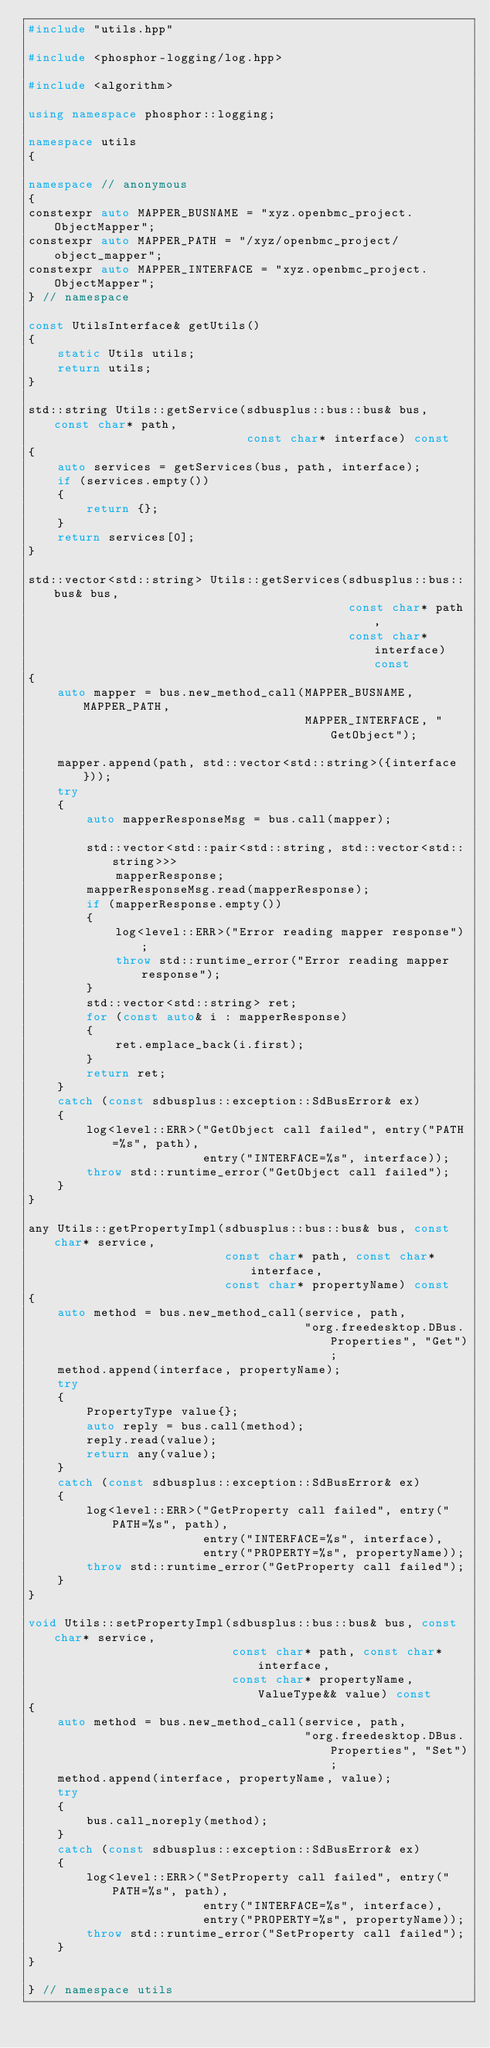Convert code to text. <code><loc_0><loc_0><loc_500><loc_500><_C++_>#include "utils.hpp"

#include <phosphor-logging/log.hpp>

#include <algorithm>

using namespace phosphor::logging;

namespace utils
{

namespace // anonymous
{
constexpr auto MAPPER_BUSNAME = "xyz.openbmc_project.ObjectMapper";
constexpr auto MAPPER_PATH = "/xyz/openbmc_project/object_mapper";
constexpr auto MAPPER_INTERFACE = "xyz.openbmc_project.ObjectMapper";
} // namespace

const UtilsInterface& getUtils()
{
    static Utils utils;
    return utils;
}

std::string Utils::getService(sdbusplus::bus::bus& bus, const char* path,
                              const char* interface) const
{
    auto services = getServices(bus, path, interface);
    if (services.empty())
    {
        return {};
    }
    return services[0];
}

std::vector<std::string> Utils::getServices(sdbusplus::bus::bus& bus,
                                            const char* path,
                                            const char* interface) const
{
    auto mapper = bus.new_method_call(MAPPER_BUSNAME, MAPPER_PATH,
                                      MAPPER_INTERFACE, "GetObject");

    mapper.append(path, std::vector<std::string>({interface}));
    try
    {
        auto mapperResponseMsg = bus.call(mapper);

        std::vector<std::pair<std::string, std::vector<std::string>>>
            mapperResponse;
        mapperResponseMsg.read(mapperResponse);
        if (mapperResponse.empty())
        {
            log<level::ERR>("Error reading mapper response");
            throw std::runtime_error("Error reading mapper response");
        }
        std::vector<std::string> ret;
        for (const auto& i : mapperResponse)
        {
            ret.emplace_back(i.first);
        }
        return ret;
    }
    catch (const sdbusplus::exception::SdBusError& ex)
    {
        log<level::ERR>("GetObject call failed", entry("PATH=%s", path),
                        entry("INTERFACE=%s", interface));
        throw std::runtime_error("GetObject call failed");
    }
}

any Utils::getPropertyImpl(sdbusplus::bus::bus& bus, const char* service,
                           const char* path, const char* interface,
                           const char* propertyName) const
{
    auto method = bus.new_method_call(service, path,
                                      "org.freedesktop.DBus.Properties", "Get");
    method.append(interface, propertyName);
    try
    {
        PropertyType value{};
        auto reply = bus.call(method);
        reply.read(value);
        return any(value);
    }
    catch (const sdbusplus::exception::SdBusError& ex)
    {
        log<level::ERR>("GetProperty call failed", entry("PATH=%s", path),
                        entry("INTERFACE=%s", interface),
                        entry("PROPERTY=%s", propertyName));
        throw std::runtime_error("GetProperty call failed");
    }
}

void Utils::setPropertyImpl(sdbusplus::bus::bus& bus, const char* service,
                            const char* path, const char* interface,
                            const char* propertyName, ValueType&& value) const
{
    auto method = bus.new_method_call(service, path,
                                      "org.freedesktop.DBus.Properties", "Set");
    method.append(interface, propertyName, value);
    try
    {
        bus.call_noreply(method);
    }
    catch (const sdbusplus::exception::SdBusError& ex)
    {
        log<level::ERR>("SetProperty call failed", entry("PATH=%s", path),
                        entry("INTERFACE=%s", interface),
                        entry("PROPERTY=%s", propertyName));
        throw std::runtime_error("SetProperty call failed");
    }
}

} // namespace utils
</code> 